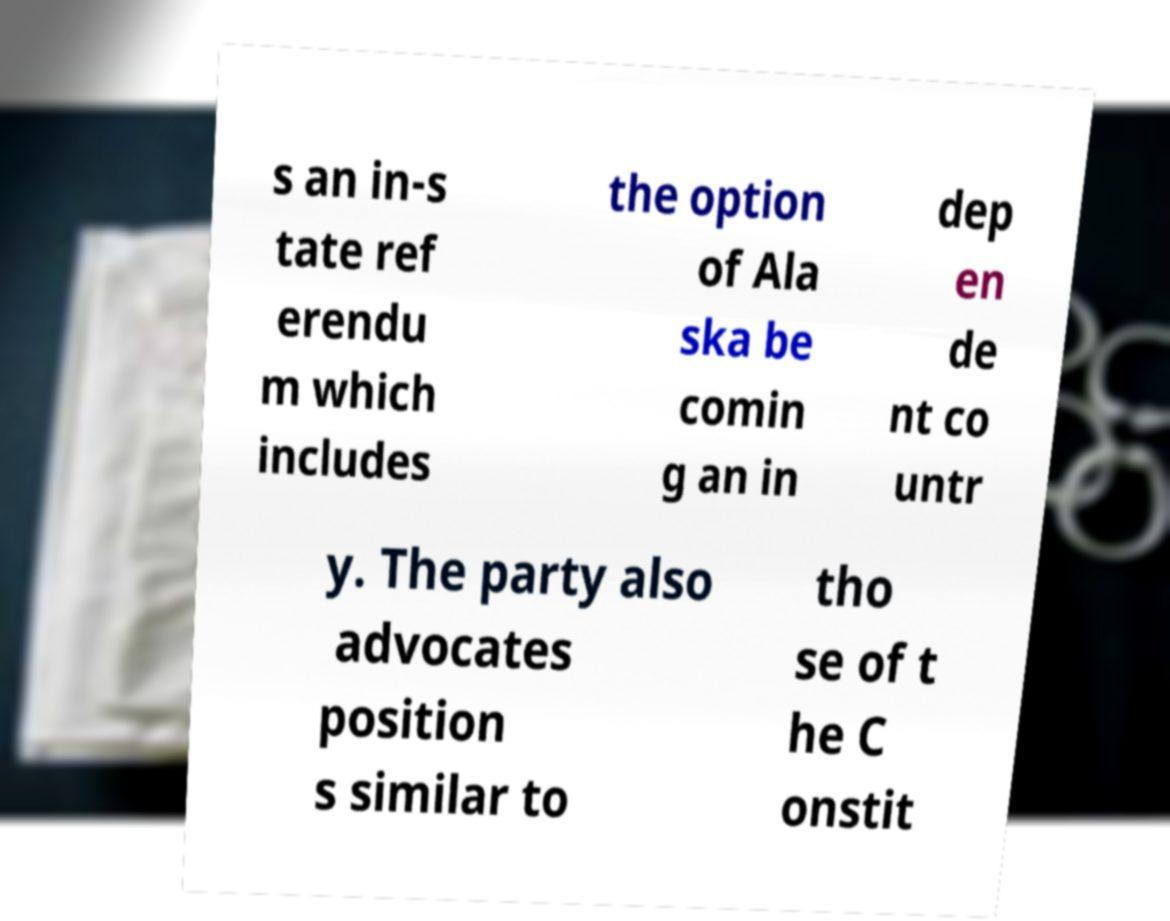There's text embedded in this image that I need extracted. Can you transcribe it verbatim? s an in-s tate ref erendu m which includes the option of Ala ska be comin g an in dep en de nt co untr y. The party also advocates position s similar to tho se of t he C onstit 